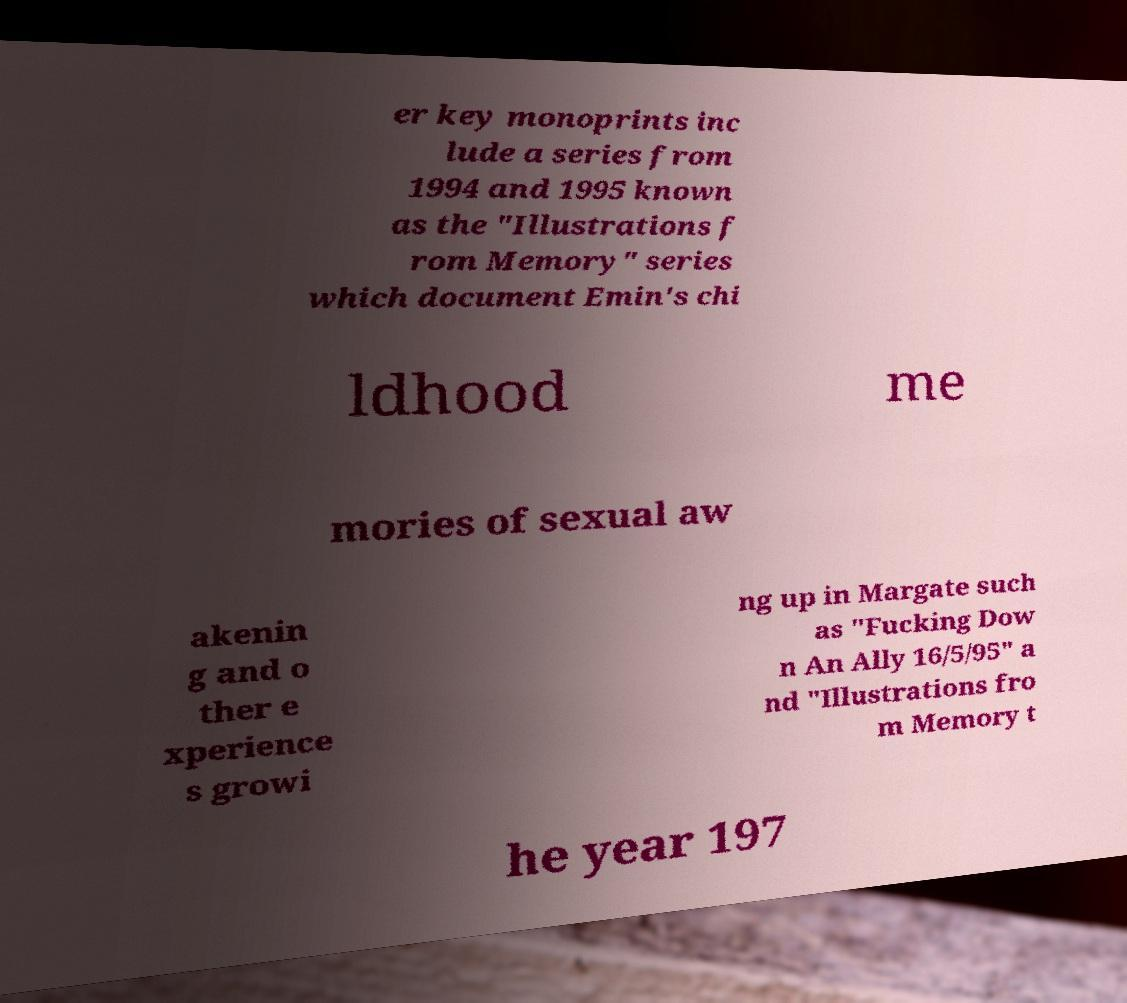Could you assist in decoding the text presented in this image and type it out clearly? er key monoprints inc lude a series from 1994 and 1995 known as the "Illustrations f rom Memory" series which document Emin's chi ldhood me mories of sexual aw akenin g and o ther e xperience s growi ng up in Margate such as "Fucking Dow n An Ally 16/5/95" a nd "Illustrations fro m Memory t he year 197 